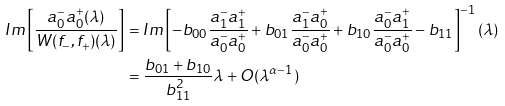Convert formula to latex. <formula><loc_0><loc_0><loc_500><loc_500>I m \left [ \frac { a _ { 0 } ^ { - } a _ { 0 } ^ { + } ( \lambda ) } { W ( f _ { - } , f _ { + } ) ( \lambda ) } \right ] & = I m \left [ - b _ { 0 0 } \frac { a _ { 1 } ^ { - } a _ { 1 } ^ { + } } { a _ { 0 } ^ { - } a _ { 0 } ^ { + } } + b _ { 0 1 } \frac { a _ { 1 } ^ { - } a _ { 0 } ^ { + } } { a _ { 0 } ^ { - } a _ { 0 } ^ { + } } + b _ { 1 0 } \frac { a _ { 0 } ^ { - } a _ { 1 } ^ { + } } { a _ { 0 } ^ { - } a _ { 0 } ^ { + } } - b _ { 1 1 } \right ] ^ { - 1 } ( \lambda ) \\ & = \frac { b _ { 0 1 } + b _ { 1 0 } } { b ^ { 2 } _ { 1 1 } } \lambda + O ( \lambda ^ { \alpha - 1 } )</formula> 